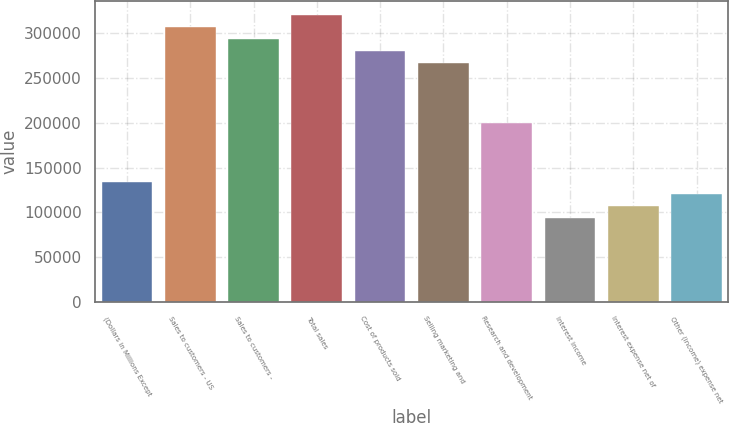Convert chart to OTSL. <chart><loc_0><loc_0><loc_500><loc_500><bar_chart><fcel>(Dollars in Millions Except<fcel>Sales to customers - US<fcel>Sales to customers -<fcel>Total sales<fcel>Cost of products sold<fcel>Selling marketing and<fcel>Research and development<fcel>Interest income<fcel>Interest expense net of<fcel>Other (income) expense net<nl><fcel>133411<fcel>306842<fcel>293501<fcel>320182<fcel>280160<fcel>266819<fcel>200115<fcel>93388.6<fcel>106729<fcel>120070<nl></chart> 